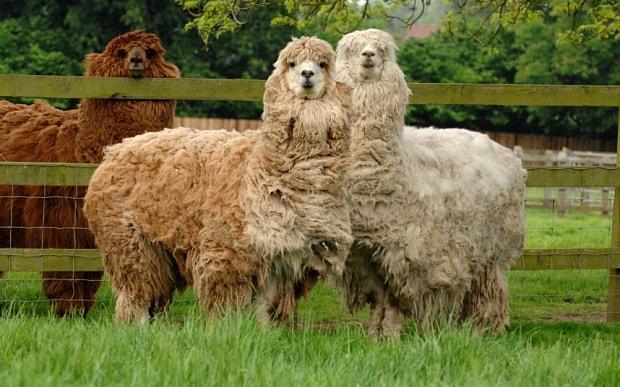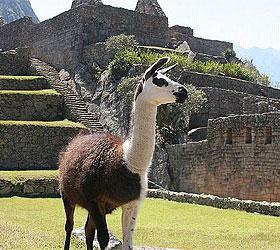The first image is the image on the left, the second image is the image on the right. Considering the images on both sides, is "There are three llamas standing in the left image." valid? Answer yes or no. Yes. 